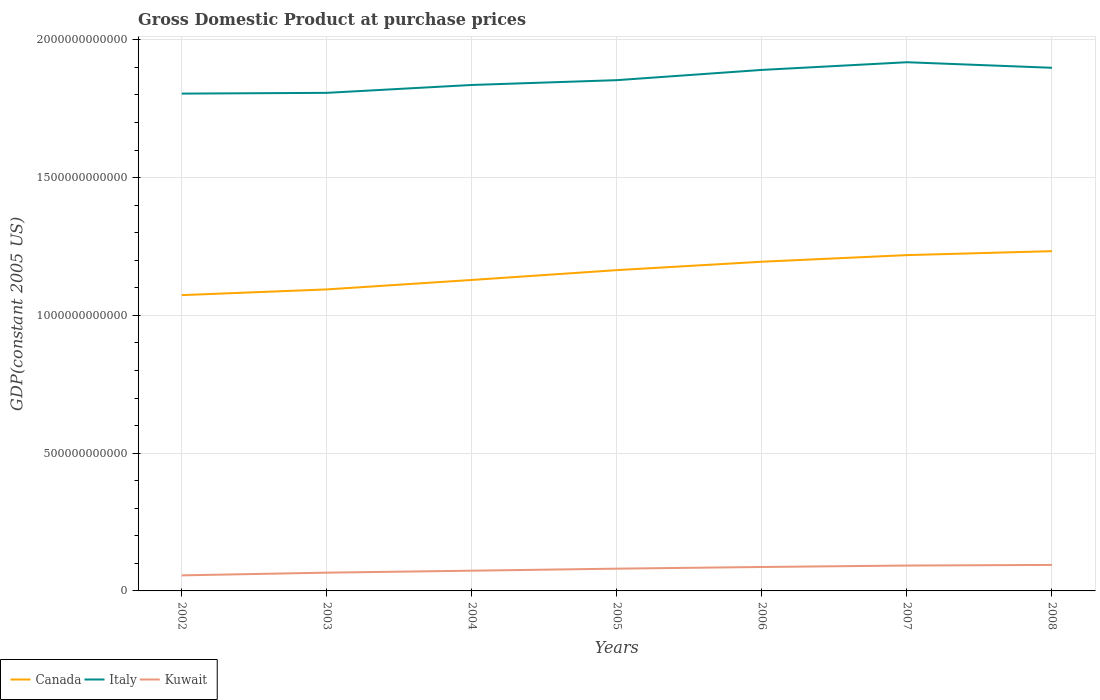Across all years, what is the maximum GDP at purchase prices in Italy?
Your answer should be very brief. 1.80e+12. What is the total GDP at purchase prices in Italy in the graph?
Offer a terse response. -4.49e+1. What is the difference between the highest and the second highest GDP at purchase prices in Kuwait?
Make the answer very short. 3.79e+1. Is the GDP at purchase prices in Kuwait strictly greater than the GDP at purchase prices in Italy over the years?
Keep it short and to the point. Yes. How many lines are there?
Offer a terse response. 3. What is the difference between two consecutive major ticks on the Y-axis?
Provide a succinct answer. 5.00e+11. Are the values on the major ticks of Y-axis written in scientific E-notation?
Provide a short and direct response. No. Does the graph contain any zero values?
Make the answer very short. No. Does the graph contain grids?
Your answer should be compact. Yes. How are the legend labels stacked?
Provide a succinct answer. Horizontal. What is the title of the graph?
Provide a short and direct response. Gross Domestic Product at purchase prices. Does "Burundi" appear as one of the legend labels in the graph?
Offer a terse response. No. What is the label or title of the X-axis?
Provide a short and direct response. Years. What is the label or title of the Y-axis?
Give a very brief answer. GDP(constant 2005 US). What is the GDP(constant 2005 US) of Canada in 2002?
Keep it short and to the point. 1.07e+12. What is the GDP(constant 2005 US) in Italy in 2002?
Your response must be concise. 1.80e+12. What is the GDP(constant 2005 US) of Kuwait in 2002?
Provide a short and direct response. 5.65e+1. What is the GDP(constant 2005 US) in Canada in 2003?
Provide a succinct answer. 1.09e+12. What is the GDP(constant 2005 US) in Italy in 2003?
Give a very brief answer. 1.81e+12. What is the GDP(constant 2005 US) in Kuwait in 2003?
Provide a succinct answer. 6.63e+1. What is the GDP(constant 2005 US) of Canada in 2004?
Give a very brief answer. 1.13e+12. What is the GDP(constant 2005 US) of Italy in 2004?
Keep it short and to the point. 1.84e+12. What is the GDP(constant 2005 US) of Kuwait in 2004?
Make the answer very short. 7.34e+1. What is the GDP(constant 2005 US) of Canada in 2005?
Provide a succinct answer. 1.16e+12. What is the GDP(constant 2005 US) in Italy in 2005?
Provide a short and direct response. 1.85e+12. What is the GDP(constant 2005 US) in Kuwait in 2005?
Ensure brevity in your answer.  8.08e+1. What is the GDP(constant 2005 US) of Canada in 2006?
Ensure brevity in your answer.  1.19e+12. What is the GDP(constant 2005 US) in Italy in 2006?
Offer a terse response. 1.89e+12. What is the GDP(constant 2005 US) in Kuwait in 2006?
Your answer should be very brief. 8.69e+1. What is the GDP(constant 2005 US) of Canada in 2007?
Offer a very short reply. 1.22e+12. What is the GDP(constant 2005 US) of Italy in 2007?
Keep it short and to the point. 1.92e+12. What is the GDP(constant 2005 US) in Kuwait in 2007?
Give a very brief answer. 9.21e+1. What is the GDP(constant 2005 US) in Canada in 2008?
Your answer should be compact. 1.23e+12. What is the GDP(constant 2005 US) in Italy in 2008?
Ensure brevity in your answer.  1.90e+12. What is the GDP(constant 2005 US) in Kuwait in 2008?
Offer a very short reply. 9.44e+1. Across all years, what is the maximum GDP(constant 2005 US) of Canada?
Your response must be concise. 1.23e+12. Across all years, what is the maximum GDP(constant 2005 US) in Italy?
Provide a short and direct response. 1.92e+12. Across all years, what is the maximum GDP(constant 2005 US) of Kuwait?
Make the answer very short. 9.44e+1. Across all years, what is the minimum GDP(constant 2005 US) in Canada?
Keep it short and to the point. 1.07e+12. Across all years, what is the minimum GDP(constant 2005 US) of Italy?
Your answer should be very brief. 1.80e+12. Across all years, what is the minimum GDP(constant 2005 US) in Kuwait?
Keep it short and to the point. 5.65e+1. What is the total GDP(constant 2005 US) of Canada in the graph?
Keep it short and to the point. 8.11e+12. What is the total GDP(constant 2005 US) in Italy in the graph?
Ensure brevity in your answer.  1.30e+13. What is the total GDP(constant 2005 US) in Kuwait in the graph?
Keep it short and to the point. 5.50e+11. What is the difference between the GDP(constant 2005 US) of Canada in 2002 and that in 2003?
Provide a short and direct response. -2.07e+1. What is the difference between the GDP(constant 2005 US) in Italy in 2002 and that in 2003?
Offer a very short reply. -2.75e+09. What is the difference between the GDP(constant 2005 US) of Kuwait in 2002 and that in 2003?
Ensure brevity in your answer.  -9.78e+09. What is the difference between the GDP(constant 2005 US) in Canada in 2002 and that in 2004?
Offer a very short reply. -5.50e+1. What is the difference between the GDP(constant 2005 US) in Italy in 2002 and that in 2004?
Provide a short and direct response. -3.14e+1. What is the difference between the GDP(constant 2005 US) in Kuwait in 2002 and that in 2004?
Give a very brief answer. -1.69e+1. What is the difference between the GDP(constant 2005 US) of Canada in 2002 and that in 2005?
Your answer should be very brief. -9.07e+1. What is the difference between the GDP(constant 2005 US) of Italy in 2002 and that in 2005?
Keep it short and to the point. -4.88e+1. What is the difference between the GDP(constant 2005 US) of Kuwait in 2002 and that in 2005?
Your answer should be very brief. -2.43e+1. What is the difference between the GDP(constant 2005 US) in Canada in 2002 and that in 2006?
Your response must be concise. -1.21e+11. What is the difference between the GDP(constant 2005 US) of Italy in 2002 and that in 2006?
Your answer should be very brief. -8.60e+1. What is the difference between the GDP(constant 2005 US) of Kuwait in 2002 and that in 2006?
Offer a terse response. -3.04e+1. What is the difference between the GDP(constant 2005 US) of Canada in 2002 and that in 2007?
Your answer should be compact. -1.45e+11. What is the difference between the GDP(constant 2005 US) of Italy in 2002 and that in 2007?
Ensure brevity in your answer.  -1.14e+11. What is the difference between the GDP(constant 2005 US) in Kuwait in 2002 and that in 2007?
Offer a very short reply. -3.56e+1. What is the difference between the GDP(constant 2005 US) of Canada in 2002 and that in 2008?
Provide a succinct answer. -1.60e+11. What is the difference between the GDP(constant 2005 US) of Italy in 2002 and that in 2008?
Provide a short and direct response. -9.37e+1. What is the difference between the GDP(constant 2005 US) of Kuwait in 2002 and that in 2008?
Provide a short and direct response. -3.79e+1. What is the difference between the GDP(constant 2005 US) in Canada in 2003 and that in 2004?
Ensure brevity in your answer.  -3.43e+1. What is the difference between the GDP(constant 2005 US) of Italy in 2003 and that in 2004?
Give a very brief answer. -2.86e+1. What is the difference between the GDP(constant 2005 US) of Kuwait in 2003 and that in 2004?
Give a very brief answer. -7.13e+09. What is the difference between the GDP(constant 2005 US) of Canada in 2003 and that in 2005?
Make the answer very short. -7.00e+1. What is the difference between the GDP(constant 2005 US) of Italy in 2003 and that in 2005?
Keep it short and to the point. -4.61e+1. What is the difference between the GDP(constant 2005 US) of Kuwait in 2003 and that in 2005?
Your response must be concise. -1.45e+1. What is the difference between the GDP(constant 2005 US) of Canada in 2003 and that in 2006?
Offer a terse response. -1.01e+11. What is the difference between the GDP(constant 2005 US) in Italy in 2003 and that in 2006?
Make the answer very short. -8.32e+1. What is the difference between the GDP(constant 2005 US) in Kuwait in 2003 and that in 2006?
Make the answer very short. -2.06e+1. What is the difference between the GDP(constant 2005 US) in Canada in 2003 and that in 2007?
Your answer should be compact. -1.25e+11. What is the difference between the GDP(constant 2005 US) in Italy in 2003 and that in 2007?
Your answer should be very brief. -1.11e+11. What is the difference between the GDP(constant 2005 US) of Kuwait in 2003 and that in 2007?
Ensure brevity in your answer.  -2.58e+1. What is the difference between the GDP(constant 2005 US) in Canada in 2003 and that in 2008?
Offer a very short reply. -1.39e+11. What is the difference between the GDP(constant 2005 US) in Italy in 2003 and that in 2008?
Offer a very short reply. -9.10e+1. What is the difference between the GDP(constant 2005 US) of Kuwait in 2003 and that in 2008?
Make the answer very short. -2.81e+1. What is the difference between the GDP(constant 2005 US) of Canada in 2004 and that in 2005?
Your response must be concise. -3.57e+1. What is the difference between the GDP(constant 2005 US) in Italy in 2004 and that in 2005?
Offer a very short reply. -1.74e+1. What is the difference between the GDP(constant 2005 US) in Kuwait in 2004 and that in 2005?
Make the answer very short. -7.40e+09. What is the difference between the GDP(constant 2005 US) in Canada in 2004 and that in 2006?
Your response must be concise. -6.62e+1. What is the difference between the GDP(constant 2005 US) of Italy in 2004 and that in 2006?
Offer a very short reply. -5.46e+1. What is the difference between the GDP(constant 2005 US) in Kuwait in 2004 and that in 2006?
Make the answer very short. -1.35e+1. What is the difference between the GDP(constant 2005 US) in Canada in 2004 and that in 2007?
Your response must be concise. -9.02e+1. What is the difference between the GDP(constant 2005 US) of Italy in 2004 and that in 2007?
Offer a terse response. -8.25e+1. What is the difference between the GDP(constant 2005 US) in Kuwait in 2004 and that in 2007?
Provide a succinct answer. -1.87e+1. What is the difference between the GDP(constant 2005 US) of Canada in 2004 and that in 2008?
Your response must be concise. -1.05e+11. What is the difference between the GDP(constant 2005 US) of Italy in 2004 and that in 2008?
Offer a terse response. -6.24e+1. What is the difference between the GDP(constant 2005 US) of Kuwait in 2004 and that in 2008?
Give a very brief answer. -2.10e+1. What is the difference between the GDP(constant 2005 US) of Canada in 2005 and that in 2006?
Offer a terse response. -3.05e+1. What is the difference between the GDP(constant 2005 US) of Italy in 2005 and that in 2006?
Ensure brevity in your answer.  -3.72e+1. What is the difference between the GDP(constant 2005 US) in Kuwait in 2005 and that in 2006?
Make the answer very short. -6.08e+09. What is the difference between the GDP(constant 2005 US) in Canada in 2005 and that in 2007?
Provide a succinct answer. -5.45e+1. What is the difference between the GDP(constant 2005 US) of Italy in 2005 and that in 2007?
Ensure brevity in your answer.  -6.51e+1. What is the difference between the GDP(constant 2005 US) of Kuwait in 2005 and that in 2007?
Your response must be concise. -1.13e+1. What is the difference between the GDP(constant 2005 US) of Canada in 2005 and that in 2008?
Your response must be concise. -6.88e+1. What is the difference between the GDP(constant 2005 US) in Italy in 2005 and that in 2008?
Your answer should be compact. -4.49e+1. What is the difference between the GDP(constant 2005 US) in Kuwait in 2005 and that in 2008?
Your response must be concise. -1.36e+1. What is the difference between the GDP(constant 2005 US) of Canada in 2006 and that in 2007?
Provide a succinct answer. -2.40e+1. What is the difference between the GDP(constant 2005 US) in Italy in 2006 and that in 2007?
Ensure brevity in your answer.  -2.79e+1. What is the difference between the GDP(constant 2005 US) of Kuwait in 2006 and that in 2007?
Offer a terse response. -5.21e+09. What is the difference between the GDP(constant 2005 US) of Canada in 2006 and that in 2008?
Provide a short and direct response. -3.83e+1. What is the difference between the GDP(constant 2005 US) in Italy in 2006 and that in 2008?
Your response must be concise. -7.73e+09. What is the difference between the GDP(constant 2005 US) in Kuwait in 2006 and that in 2008?
Give a very brief answer. -7.49e+09. What is the difference between the GDP(constant 2005 US) in Canada in 2007 and that in 2008?
Ensure brevity in your answer.  -1.43e+1. What is the difference between the GDP(constant 2005 US) in Italy in 2007 and that in 2008?
Offer a terse response. 2.01e+1. What is the difference between the GDP(constant 2005 US) of Kuwait in 2007 and that in 2008?
Your answer should be compact. -2.28e+09. What is the difference between the GDP(constant 2005 US) in Canada in 2002 and the GDP(constant 2005 US) in Italy in 2003?
Provide a short and direct response. -7.34e+11. What is the difference between the GDP(constant 2005 US) in Canada in 2002 and the GDP(constant 2005 US) in Kuwait in 2003?
Provide a short and direct response. 1.01e+12. What is the difference between the GDP(constant 2005 US) of Italy in 2002 and the GDP(constant 2005 US) of Kuwait in 2003?
Provide a short and direct response. 1.74e+12. What is the difference between the GDP(constant 2005 US) in Canada in 2002 and the GDP(constant 2005 US) in Italy in 2004?
Your response must be concise. -7.63e+11. What is the difference between the GDP(constant 2005 US) of Canada in 2002 and the GDP(constant 2005 US) of Kuwait in 2004?
Make the answer very short. 1.00e+12. What is the difference between the GDP(constant 2005 US) in Italy in 2002 and the GDP(constant 2005 US) in Kuwait in 2004?
Make the answer very short. 1.73e+12. What is the difference between the GDP(constant 2005 US) in Canada in 2002 and the GDP(constant 2005 US) in Italy in 2005?
Keep it short and to the point. -7.80e+11. What is the difference between the GDP(constant 2005 US) of Canada in 2002 and the GDP(constant 2005 US) of Kuwait in 2005?
Offer a terse response. 9.93e+11. What is the difference between the GDP(constant 2005 US) in Italy in 2002 and the GDP(constant 2005 US) in Kuwait in 2005?
Provide a succinct answer. 1.72e+12. What is the difference between the GDP(constant 2005 US) in Canada in 2002 and the GDP(constant 2005 US) in Italy in 2006?
Make the answer very short. -8.17e+11. What is the difference between the GDP(constant 2005 US) in Canada in 2002 and the GDP(constant 2005 US) in Kuwait in 2006?
Ensure brevity in your answer.  9.87e+11. What is the difference between the GDP(constant 2005 US) in Italy in 2002 and the GDP(constant 2005 US) in Kuwait in 2006?
Provide a short and direct response. 1.72e+12. What is the difference between the GDP(constant 2005 US) of Canada in 2002 and the GDP(constant 2005 US) of Italy in 2007?
Make the answer very short. -8.45e+11. What is the difference between the GDP(constant 2005 US) in Canada in 2002 and the GDP(constant 2005 US) in Kuwait in 2007?
Your answer should be compact. 9.81e+11. What is the difference between the GDP(constant 2005 US) in Italy in 2002 and the GDP(constant 2005 US) in Kuwait in 2007?
Make the answer very short. 1.71e+12. What is the difference between the GDP(constant 2005 US) in Canada in 2002 and the GDP(constant 2005 US) in Italy in 2008?
Provide a short and direct response. -8.25e+11. What is the difference between the GDP(constant 2005 US) of Canada in 2002 and the GDP(constant 2005 US) of Kuwait in 2008?
Your answer should be very brief. 9.79e+11. What is the difference between the GDP(constant 2005 US) of Italy in 2002 and the GDP(constant 2005 US) of Kuwait in 2008?
Keep it short and to the point. 1.71e+12. What is the difference between the GDP(constant 2005 US) in Canada in 2003 and the GDP(constant 2005 US) in Italy in 2004?
Your answer should be very brief. -7.42e+11. What is the difference between the GDP(constant 2005 US) in Canada in 2003 and the GDP(constant 2005 US) in Kuwait in 2004?
Make the answer very short. 1.02e+12. What is the difference between the GDP(constant 2005 US) in Italy in 2003 and the GDP(constant 2005 US) in Kuwait in 2004?
Give a very brief answer. 1.73e+12. What is the difference between the GDP(constant 2005 US) of Canada in 2003 and the GDP(constant 2005 US) of Italy in 2005?
Your answer should be very brief. -7.59e+11. What is the difference between the GDP(constant 2005 US) in Canada in 2003 and the GDP(constant 2005 US) in Kuwait in 2005?
Give a very brief answer. 1.01e+12. What is the difference between the GDP(constant 2005 US) of Italy in 2003 and the GDP(constant 2005 US) of Kuwait in 2005?
Offer a terse response. 1.73e+12. What is the difference between the GDP(constant 2005 US) of Canada in 2003 and the GDP(constant 2005 US) of Italy in 2006?
Make the answer very short. -7.97e+11. What is the difference between the GDP(constant 2005 US) of Canada in 2003 and the GDP(constant 2005 US) of Kuwait in 2006?
Ensure brevity in your answer.  1.01e+12. What is the difference between the GDP(constant 2005 US) of Italy in 2003 and the GDP(constant 2005 US) of Kuwait in 2006?
Ensure brevity in your answer.  1.72e+12. What is the difference between the GDP(constant 2005 US) in Canada in 2003 and the GDP(constant 2005 US) in Italy in 2007?
Provide a succinct answer. -8.24e+11. What is the difference between the GDP(constant 2005 US) of Canada in 2003 and the GDP(constant 2005 US) of Kuwait in 2007?
Your answer should be compact. 1.00e+12. What is the difference between the GDP(constant 2005 US) in Italy in 2003 and the GDP(constant 2005 US) in Kuwait in 2007?
Offer a terse response. 1.72e+12. What is the difference between the GDP(constant 2005 US) in Canada in 2003 and the GDP(constant 2005 US) in Italy in 2008?
Provide a succinct answer. -8.04e+11. What is the difference between the GDP(constant 2005 US) of Canada in 2003 and the GDP(constant 2005 US) of Kuwait in 2008?
Keep it short and to the point. 1.00e+12. What is the difference between the GDP(constant 2005 US) in Italy in 2003 and the GDP(constant 2005 US) in Kuwait in 2008?
Your answer should be very brief. 1.71e+12. What is the difference between the GDP(constant 2005 US) in Canada in 2004 and the GDP(constant 2005 US) in Italy in 2005?
Your response must be concise. -7.25e+11. What is the difference between the GDP(constant 2005 US) in Canada in 2004 and the GDP(constant 2005 US) in Kuwait in 2005?
Your answer should be very brief. 1.05e+12. What is the difference between the GDP(constant 2005 US) of Italy in 2004 and the GDP(constant 2005 US) of Kuwait in 2005?
Provide a succinct answer. 1.76e+12. What is the difference between the GDP(constant 2005 US) in Canada in 2004 and the GDP(constant 2005 US) in Italy in 2006?
Give a very brief answer. -7.62e+11. What is the difference between the GDP(constant 2005 US) of Canada in 2004 and the GDP(constant 2005 US) of Kuwait in 2006?
Give a very brief answer. 1.04e+12. What is the difference between the GDP(constant 2005 US) in Italy in 2004 and the GDP(constant 2005 US) in Kuwait in 2006?
Your response must be concise. 1.75e+12. What is the difference between the GDP(constant 2005 US) of Canada in 2004 and the GDP(constant 2005 US) of Italy in 2007?
Your answer should be very brief. -7.90e+11. What is the difference between the GDP(constant 2005 US) of Canada in 2004 and the GDP(constant 2005 US) of Kuwait in 2007?
Ensure brevity in your answer.  1.04e+12. What is the difference between the GDP(constant 2005 US) in Italy in 2004 and the GDP(constant 2005 US) in Kuwait in 2007?
Provide a succinct answer. 1.74e+12. What is the difference between the GDP(constant 2005 US) in Canada in 2004 and the GDP(constant 2005 US) in Italy in 2008?
Ensure brevity in your answer.  -7.70e+11. What is the difference between the GDP(constant 2005 US) of Canada in 2004 and the GDP(constant 2005 US) of Kuwait in 2008?
Ensure brevity in your answer.  1.03e+12. What is the difference between the GDP(constant 2005 US) in Italy in 2004 and the GDP(constant 2005 US) in Kuwait in 2008?
Provide a succinct answer. 1.74e+12. What is the difference between the GDP(constant 2005 US) of Canada in 2005 and the GDP(constant 2005 US) of Italy in 2006?
Provide a short and direct response. -7.27e+11. What is the difference between the GDP(constant 2005 US) of Canada in 2005 and the GDP(constant 2005 US) of Kuwait in 2006?
Offer a terse response. 1.08e+12. What is the difference between the GDP(constant 2005 US) in Italy in 2005 and the GDP(constant 2005 US) in Kuwait in 2006?
Your answer should be compact. 1.77e+12. What is the difference between the GDP(constant 2005 US) in Canada in 2005 and the GDP(constant 2005 US) in Italy in 2007?
Provide a short and direct response. -7.54e+11. What is the difference between the GDP(constant 2005 US) in Canada in 2005 and the GDP(constant 2005 US) in Kuwait in 2007?
Your response must be concise. 1.07e+12. What is the difference between the GDP(constant 2005 US) in Italy in 2005 and the GDP(constant 2005 US) in Kuwait in 2007?
Make the answer very short. 1.76e+12. What is the difference between the GDP(constant 2005 US) of Canada in 2005 and the GDP(constant 2005 US) of Italy in 2008?
Make the answer very short. -7.34e+11. What is the difference between the GDP(constant 2005 US) of Canada in 2005 and the GDP(constant 2005 US) of Kuwait in 2008?
Ensure brevity in your answer.  1.07e+12. What is the difference between the GDP(constant 2005 US) of Italy in 2005 and the GDP(constant 2005 US) of Kuwait in 2008?
Your answer should be compact. 1.76e+12. What is the difference between the GDP(constant 2005 US) of Canada in 2006 and the GDP(constant 2005 US) of Italy in 2007?
Offer a very short reply. -7.24e+11. What is the difference between the GDP(constant 2005 US) in Canada in 2006 and the GDP(constant 2005 US) in Kuwait in 2007?
Make the answer very short. 1.10e+12. What is the difference between the GDP(constant 2005 US) in Italy in 2006 and the GDP(constant 2005 US) in Kuwait in 2007?
Give a very brief answer. 1.80e+12. What is the difference between the GDP(constant 2005 US) in Canada in 2006 and the GDP(constant 2005 US) in Italy in 2008?
Provide a short and direct response. -7.04e+11. What is the difference between the GDP(constant 2005 US) of Canada in 2006 and the GDP(constant 2005 US) of Kuwait in 2008?
Ensure brevity in your answer.  1.10e+12. What is the difference between the GDP(constant 2005 US) of Italy in 2006 and the GDP(constant 2005 US) of Kuwait in 2008?
Provide a succinct answer. 1.80e+12. What is the difference between the GDP(constant 2005 US) of Canada in 2007 and the GDP(constant 2005 US) of Italy in 2008?
Make the answer very short. -6.80e+11. What is the difference between the GDP(constant 2005 US) in Canada in 2007 and the GDP(constant 2005 US) in Kuwait in 2008?
Give a very brief answer. 1.12e+12. What is the difference between the GDP(constant 2005 US) of Italy in 2007 and the GDP(constant 2005 US) of Kuwait in 2008?
Give a very brief answer. 1.82e+12. What is the average GDP(constant 2005 US) in Canada per year?
Your answer should be very brief. 1.16e+12. What is the average GDP(constant 2005 US) of Italy per year?
Provide a succinct answer. 1.86e+12. What is the average GDP(constant 2005 US) of Kuwait per year?
Your answer should be very brief. 7.86e+1. In the year 2002, what is the difference between the GDP(constant 2005 US) in Canada and GDP(constant 2005 US) in Italy?
Make the answer very short. -7.31e+11. In the year 2002, what is the difference between the GDP(constant 2005 US) of Canada and GDP(constant 2005 US) of Kuwait?
Provide a short and direct response. 1.02e+12. In the year 2002, what is the difference between the GDP(constant 2005 US) of Italy and GDP(constant 2005 US) of Kuwait?
Your answer should be compact. 1.75e+12. In the year 2003, what is the difference between the GDP(constant 2005 US) in Canada and GDP(constant 2005 US) in Italy?
Offer a very short reply. -7.13e+11. In the year 2003, what is the difference between the GDP(constant 2005 US) of Canada and GDP(constant 2005 US) of Kuwait?
Your answer should be very brief. 1.03e+12. In the year 2003, what is the difference between the GDP(constant 2005 US) in Italy and GDP(constant 2005 US) in Kuwait?
Your answer should be very brief. 1.74e+12. In the year 2004, what is the difference between the GDP(constant 2005 US) in Canada and GDP(constant 2005 US) in Italy?
Provide a short and direct response. -7.08e+11. In the year 2004, what is the difference between the GDP(constant 2005 US) in Canada and GDP(constant 2005 US) in Kuwait?
Provide a short and direct response. 1.06e+12. In the year 2004, what is the difference between the GDP(constant 2005 US) of Italy and GDP(constant 2005 US) of Kuwait?
Your answer should be compact. 1.76e+12. In the year 2005, what is the difference between the GDP(constant 2005 US) in Canada and GDP(constant 2005 US) in Italy?
Keep it short and to the point. -6.89e+11. In the year 2005, what is the difference between the GDP(constant 2005 US) in Canada and GDP(constant 2005 US) in Kuwait?
Your answer should be very brief. 1.08e+12. In the year 2005, what is the difference between the GDP(constant 2005 US) in Italy and GDP(constant 2005 US) in Kuwait?
Make the answer very short. 1.77e+12. In the year 2006, what is the difference between the GDP(constant 2005 US) of Canada and GDP(constant 2005 US) of Italy?
Make the answer very short. -6.96e+11. In the year 2006, what is the difference between the GDP(constant 2005 US) of Canada and GDP(constant 2005 US) of Kuwait?
Ensure brevity in your answer.  1.11e+12. In the year 2006, what is the difference between the GDP(constant 2005 US) of Italy and GDP(constant 2005 US) of Kuwait?
Keep it short and to the point. 1.80e+12. In the year 2007, what is the difference between the GDP(constant 2005 US) in Canada and GDP(constant 2005 US) in Italy?
Give a very brief answer. -7.00e+11. In the year 2007, what is the difference between the GDP(constant 2005 US) in Canada and GDP(constant 2005 US) in Kuwait?
Your response must be concise. 1.13e+12. In the year 2007, what is the difference between the GDP(constant 2005 US) in Italy and GDP(constant 2005 US) in Kuwait?
Give a very brief answer. 1.83e+12. In the year 2008, what is the difference between the GDP(constant 2005 US) of Canada and GDP(constant 2005 US) of Italy?
Keep it short and to the point. -6.65e+11. In the year 2008, what is the difference between the GDP(constant 2005 US) of Canada and GDP(constant 2005 US) of Kuwait?
Provide a succinct answer. 1.14e+12. In the year 2008, what is the difference between the GDP(constant 2005 US) of Italy and GDP(constant 2005 US) of Kuwait?
Make the answer very short. 1.80e+12. What is the ratio of the GDP(constant 2005 US) in Canada in 2002 to that in 2003?
Your answer should be very brief. 0.98. What is the ratio of the GDP(constant 2005 US) of Kuwait in 2002 to that in 2003?
Your answer should be compact. 0.85. What is the ratio of the GDP(constant 2005 US) in Canada in 2002 to that in 2004?
Offer a very short reply. 0.95. What is the ratio of the GDP(constant 2005 US) of Italy in 2002 to that in 2004?
Your answer should be compact. 0.98. What is the ratio of the GDP(constant 2005 US) of Kuwait in 2002 to that in 2004?
Your answer should be very brief. 0.77. What is the ratio of the GDP(constant 2005 US) in Canada in 2002 to that in 2005?
Provide a succinct answer. 0.92. What is the ratio of the GDP(constant 2005 US) in Italy in 2002 to that in 2005?
Give a very brief answer. 0.97. What is the ratio of the GDP(constant 2005 US) of Kuwait in 2002 to that in 2005?
Your response must be concise. 0.7. What is the ratio of the GDP(constant 2005 US) in Canada in 2002 to that in 2006?
Your answer should be compact. 0.9. What is the ratio of the GDP(constant 2005 US) in Italy in 2002 to that in 2006?
Make the answer very short. 0.95. What is the ratio of the GDP(constant 2005 US) in Kuwait in 2002 to that in 2006?
Offer a very short reply. 0.65. What is the ratio of the GDP(constant 2005 US) of Canada in 2002 to that in 2007?
Your answer should be compact. 0.88. What is the ratio of the GDP(constant 2005 US) of Italy in 2002 to that in 2007?
Keep it short and to the point. 0.94. What is the ratio of the GDP(constant 2005 US) of Kuwait in 2002 to that in 2007?
Keep it short and to the point. 0.61. What is the ratio of the GDP(constant 2005 US) in Canada in 2002 to that in 2008?
Your answer should be very brief. 0.87. What is the ratio of the GDP(constant 2005 US) of Italy in 2002 to that in 2008?
Your answer should be compact. 0.95. What is the ratio of the GDP(constant 2005 US) in Kuwait in 2002 to that in 2008?
Keep it short and to the point. 0.6. What is the ratio of the GDP(constant 2005 US) of Canada in 2003 to that in 2004?
Keep it short and to the point. 0.97. What is the ratio of the GDP(constant 2005 US) in Italy in 2003 to that in 2004?
Your response must be concise. 0.98. What is the ratio of the GDP(constant 2005 US) of Kuwait in 2003 to that in 2004?
Provide a short and direct response. 0.9. What is the ratio of the GDP(constant 2005 US) of Canada in 2003 to that in 2005?
Your answer should be very brief. 0.94. What is the ratio of the GDP(constant 2005 US) of Italy in 2003 to that in 2005?
Your answer should be very brief. 0.98. What is the ratio of the GDP(constant 2005 US) of Kuwait in 2003 to that in 2005?
Your answer should be compact. 0.82. What is the ratio of the GDP(constant 2005 US) in Canada in 2003 to that in 2006?
Your answer should be compact. 0.92. What is the ratio of the GDP(constant 2005 US) of Italy in 2003 to that in 2006?
Provide a short and direct response. 0.96. What is the ratio of the GDP(constant 2005 US) of Kuwait in 2003 to that in 2006?
Keep it short and to the point. 0.76. What is the ratio of the GDP(constant 2005 US) of Canada in 2003 to that in 2007?
Your answer should be compact. 0.9. What is the ratio of the GDP(constant 2005 US) in Italy in 2003 to that in 2007?
Provide a succinct answer. 0.94. What is the ratio of the GDP(constant 2005 US) of Kuwait in 2003 to that in 2007?
Give a very brief answer. 0.72. What is the ratio of the GDP(constant 2005 US) in Canada in 2003 to that in 2008?
Offer a terse response. 0.89. What is the ratio of the GDP(constant 2005 US) in Italy in 2003 to that in 2008?
Offer a terse response. 0.95. What is the ratio of the GDP(constant 2005 US) in Kuwait in 2003 to that in 2008?
Offer a very short reply. 0.7. What is the ratio of the GDP(constant 2005 US) in Canada in 2004 to that in 2005?
Keep it short and to the point. 0.97. What is the ratio of the GDP(constant 2005 US) in Italy in 2004 to that in 2005?
Provide a succinct answer. 0.99. What is the ratio of the GDP(constant 2005 US) of Kuwait in 2004 to that in 2005?
Give a very brief answer. 0.91. What is the ratio of the GDP(constant 2005 US) of Canada in 2004 to that in 2006?
Offer a terse response. 0.94. What is the ratio of the GDP(constant 2005 US) of Italy in 2004 to that in 2006?
Provide a short and direct response. 0.97. What is the ratio of the GDP(constant 2005 US) of Kuwait in 2004 to that in 2006?
Your answer should be very brief. 0.84. What is the ratio of the GDP(constant 2005 US) of Canada in 2004 to that in 2007?
Make the answer very short. 0.93. What is the ratio of the GDP(constant 2005 US) in Italy in 2004 to that in 2007?
Provide a short and direct response. 0.96. What is the ratio of the GDP(constant 2005 US) of Kuwait in 2004 to that in 2007?
Ensure brevity in your answer.  0.8. What is the ratio of the GDP(constant 2005 US) in Canada in 2004 to that in 2008?
Your response must be concise. 0.92. What is the ratio of the GDP(constant 2005 US) in Italy in 2004 to that in 2008?
Your response must be concise. 0.97. What is the ratio of the GDP(constant 2005 US) of Kuwait in 2004 to that in 2008?
Your answer should be compact. 0.78. What is the ratio of the GDP(constant 2005 US) in Canada in 2005 to that in 2006?
Your answer should be compact. 0.97. What is the ratio of the GDP(constant 2005 US) of Italy in 2005 to that in 2006?
Make the answer very short. 0.98. What is the ratio of the GDP(constant 2005 US) of Kuwait in 2005 to that in 2006?
Keep it short and to the point. 0.93. What is the ratio of the GDP(constant 2005 US) in Canada in 2005 to that in 2007?
Offer a very short reply. 0.96. What is the ratio of the GDP(constant 2005 US) in Italy in 2005 to that in 2007?
Your answer should be compact. 0.97. What is the ratio of the GDP(constant 2005 US) of Kuwait in 2005 to that in 2007?
Give a very brief answer. 0.88. What is the ratio of the GDP(constant 2005 US) in Canada in 2005 to that in 2008?
Make the answer very short. 0.94. What is the ratio of the GDP(constant 2005 US) of Italy in 2005 to that in 2008?
Your answer should be compact. 0.98. What is the ratio of the GDP(constant 2005 US) in Kuwait in 2005 to that in 2008?
Ensure brevity in your answer.  0.86. What is the ratio of the GDP(constant 2005 US) in Canada in 2006 to that in 2007?
Your answer should be compact. 0.98. What is the ratio of the GDP(constant 2005 US) in Italy in 2006 to that in 2007?
Ensure brevity in your answer.  0.99. What is the ratio of the GDP(constant 2005 US) of Kuwait in 2006 to that in 2007?
Your answer should be compact. 0.94. What is the ratio of the GDP(constant 2005 US) of Canada in 2006 to that in 2008?
Give a very brief answer. 0.97. What is the ratio of the GDP(constant 2005 US) in Italy in 2006 to that in 2008?
Provide a short and direct response. 1. What is the ratio of the GDP(constant 2005 US) in Kuwait in 2006 to that in 2008?
Ensure brevity in your answer.  0.92. What is the ratio of the GDP(constant 2005 US) of Canada in 2007 to that in 2008?
Ensure brevity in your answer.  0.99. What is the ratio of the GDP(constant 2005 US) of Italy in 2007 to that in 2008?
Your answer should be compact. 1.01. What is the ratio of the GDP(constant 2005 US) in Kuwait in 2007 to that in 2008?
Ensure brevity in your answer.  0.98. What is the difference between the highest and the second highest GDP(constant 2005 US) in Canada?
Give a very brief answer. 1.43e+1. What is the difference between the highest and the second highest GDP(constant 2005 US) in Italy?
Your response must be concise. 2.01e+1. What is the difference between the highest and the second highest GDP(constant 2005 US) of Kuwait?
Make the answer very short. 2.28e+09. What is the difference between the highest and the lowest GDP(constant 2005 US) of Canada?
Make the answer very short. 1.60e+11. What is the difference between the highest and the lowest GDP(constant 2005 US) in Italy?
Your answer should be compact. 1.14e+11. What is the difference between the highest and the lowest GDP(constant 2005 US) of Kuwait?
Your answer should be compact. 3.79e+1. 